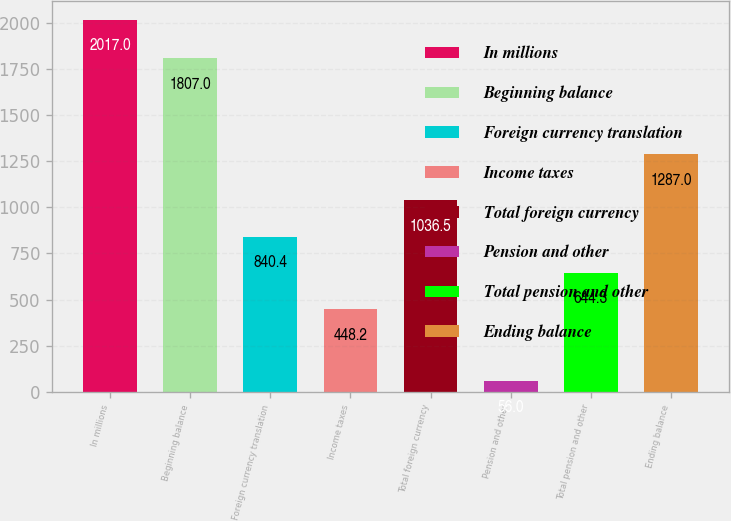Convert chart to OTSL. <chart><loc_0><loc_0><loc_500><loc_500><bar_chart><fcel>In millions<fcel>Beginning balance<fcel>Foreign currency translation<fcel>Income taxes<fcel>Total foreign currency<fcel>Pension and other<fcel>Total pension and other<fcel>Ending balance<nl><fcel>2017<fcel>1807<fcel>840.4<fcel>448.2<fcel>1036.5<fcel>56<fcel>644.3<fcel>1287<nl></chart> 